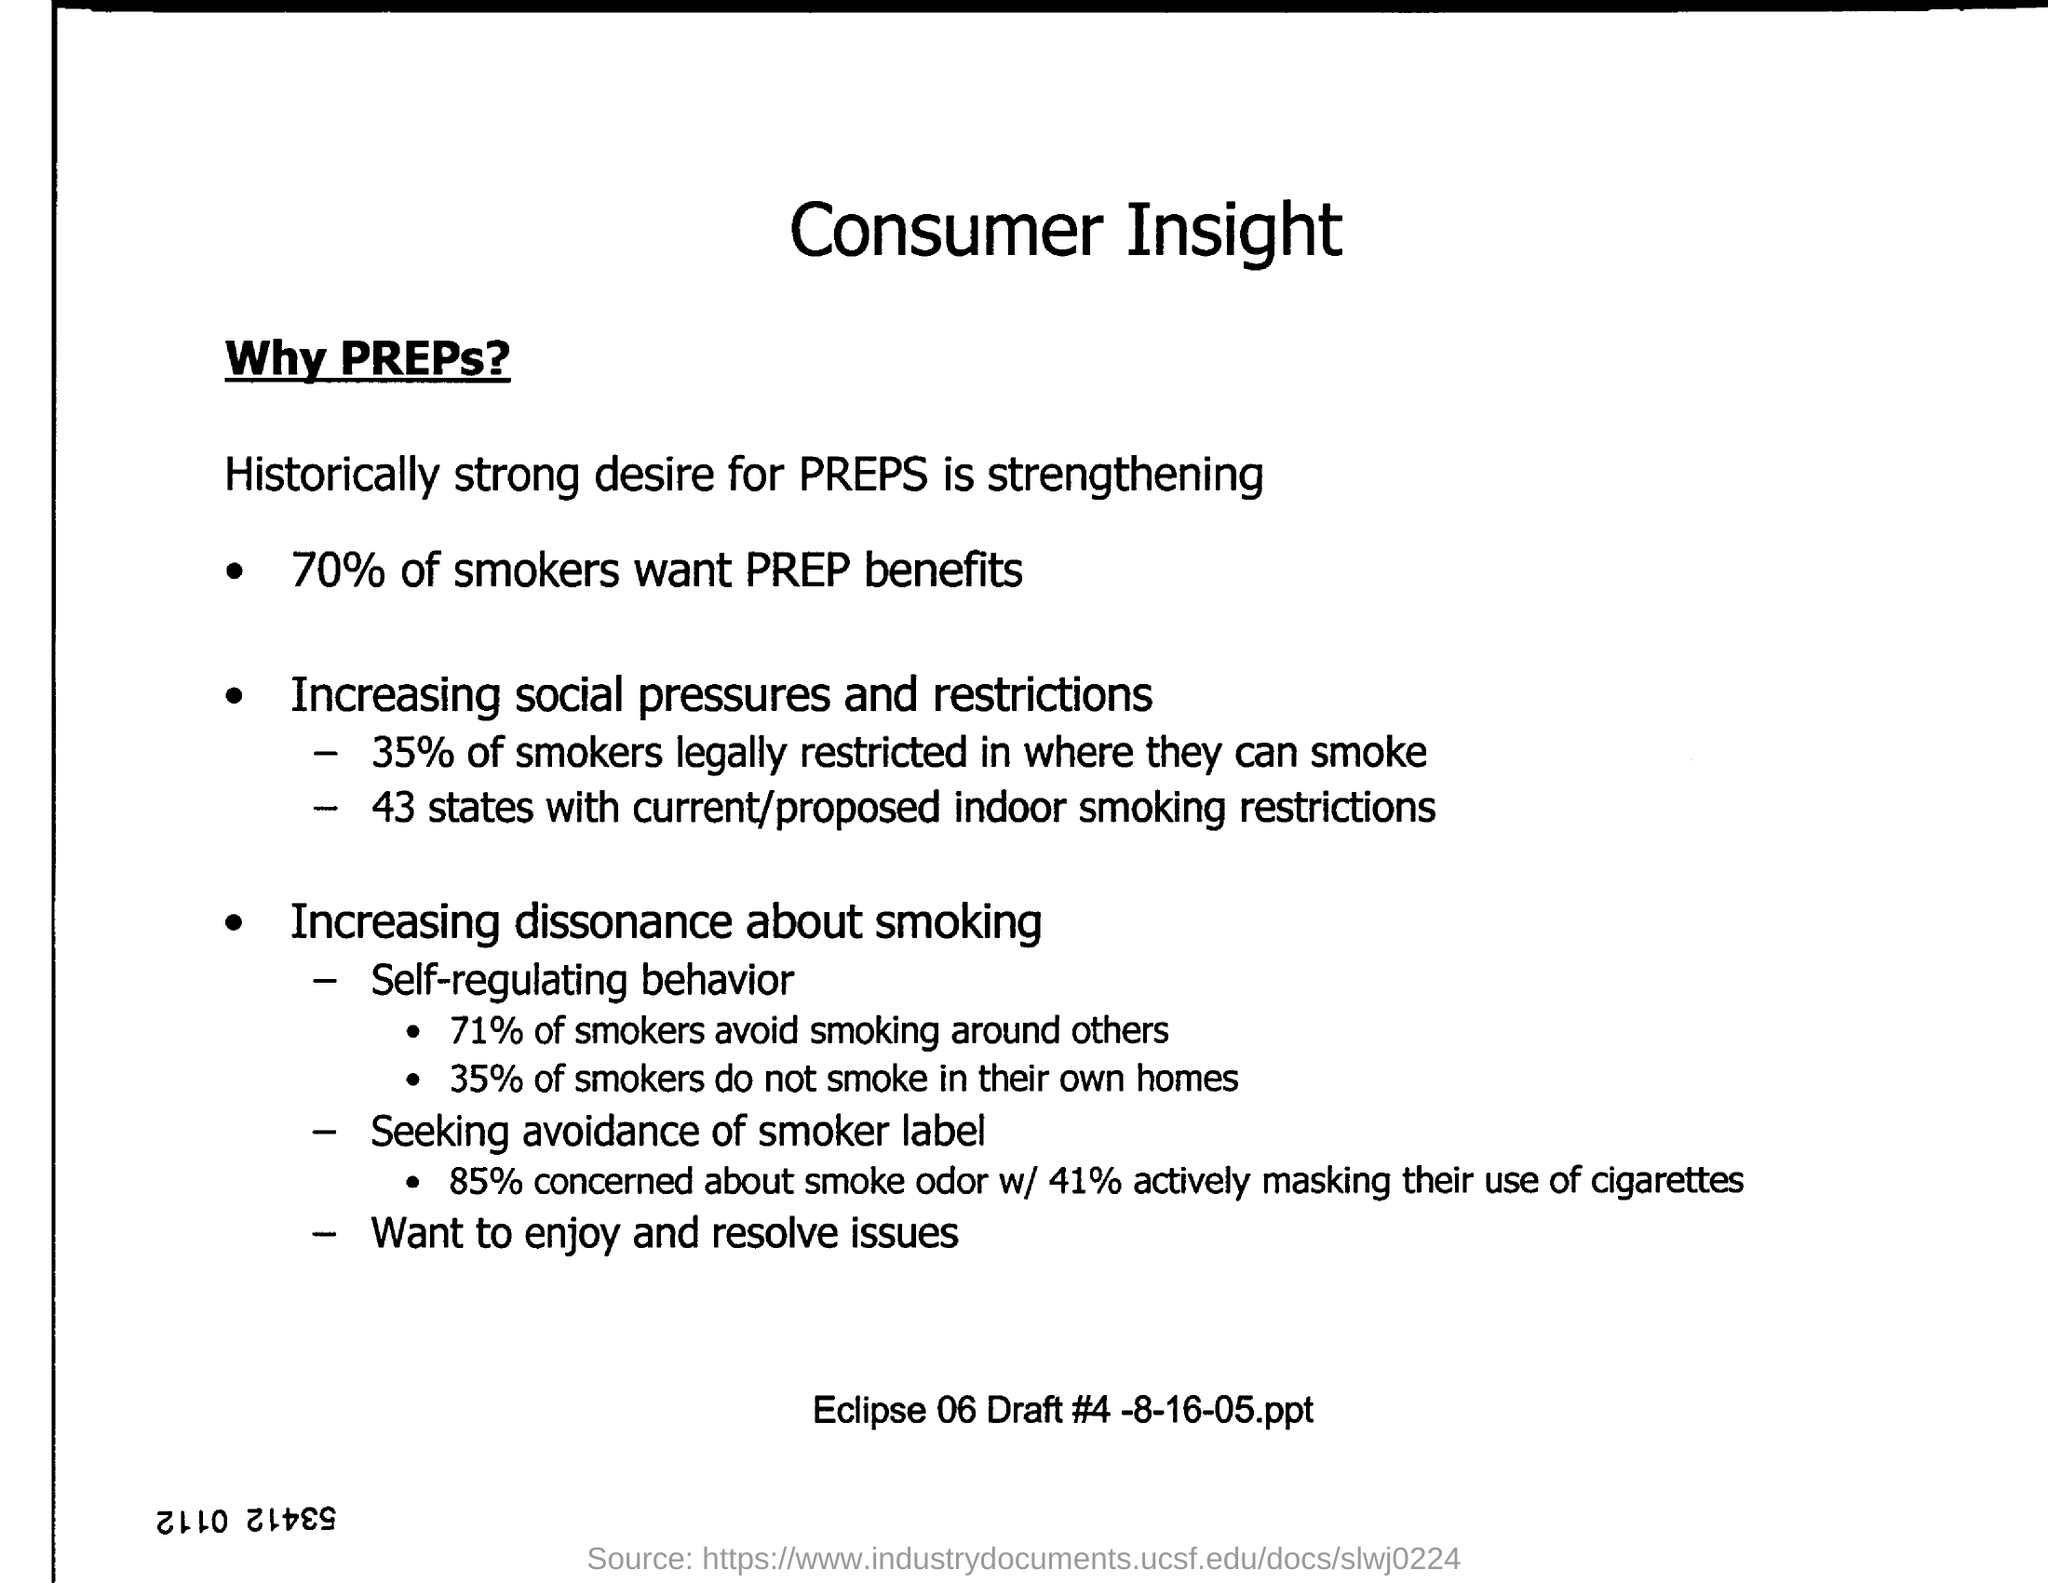How many states have current/proposed indoor smoking restrictions?
 43 